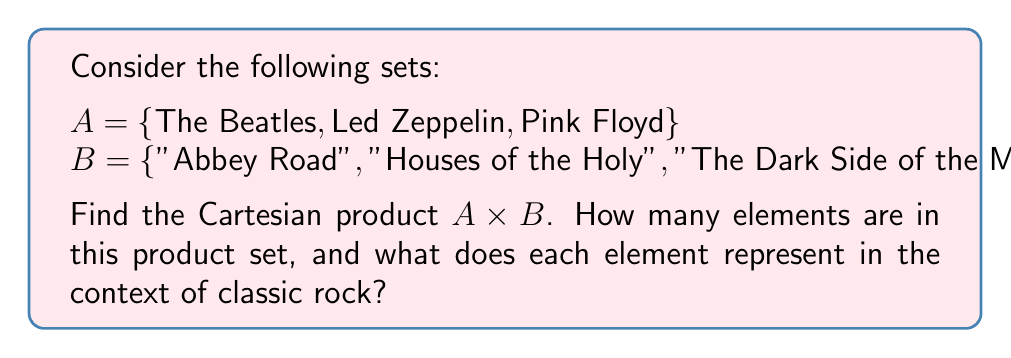Give your solution to this math problem. To solve this problem, let's follow these steps:

1) The Cartesian product $A \times B$ is defined as the set of all ordered pairs $(a,b)$ where $a \in A$ and $b \in B$.

2) We can represent this mathematically as:
   $A \times B = \{(a,b) | a \in A \text{ and } b \in B\}$

3) Let's list out all possible pairs:
   - (The Beatles, "Abbey Road")
   - (The Beatles, "Houses of the Holy")
   - (The Beatles, "The Dark Side of the Moon")
   - (Led Zeppelin, "Abbey Road")
   - (Led Zeppelin, "Houses of the Holy")
   - (Led Zeppelin, "The Dark Side of the Moon")
   - (Pink Floyd, "Abbey Road")
   - (Pink Floyd, "Houses of the Holy")
   - (Pink Floyd, "The Dark Side of the Moon")

4) To determine the number of elements in $A \times B$, we use the multiplication principle:
   $|A \times B| = |A| \cdot |B| = 3 \cdot 3 = 9$

5) In the context of classic rock, each element represents a possible pairing of a band with an album, regardless of whether that band actually created that album. This Cartesian product creates all possible combinations, including both real album-band pairs (like The Beatles and "Abbey Road") and fictional ones (like Led Zeppelin and "The Dark Side of the Moon").
Answer: $A \times B = \{(\text{The Beatles}, \text{"Abbey Road"}), (\text{The Beatles}, \text{"Houses of the Holy"}), (\text{The Beatles}, \text{"The Dark Side of the Moon"}), (\text{Led Zeppelin}, \text{"Abbey Road"}), (\text{Led Zeppelin}, \text{"Houses of the Holy"}), (\text{Led Zeppelin}, \text{"The Dark Side of the Moon"}), (\text{Pink Floyd}, \text{"Abbey Road"}), (\text{Pink Floyd}, \text{"Houses of the Holy"}), (\text{Pink Floyd}, \text{"The Dark Side of the Moon"})\}$; 9 elements; each represents a band-album pairing. 